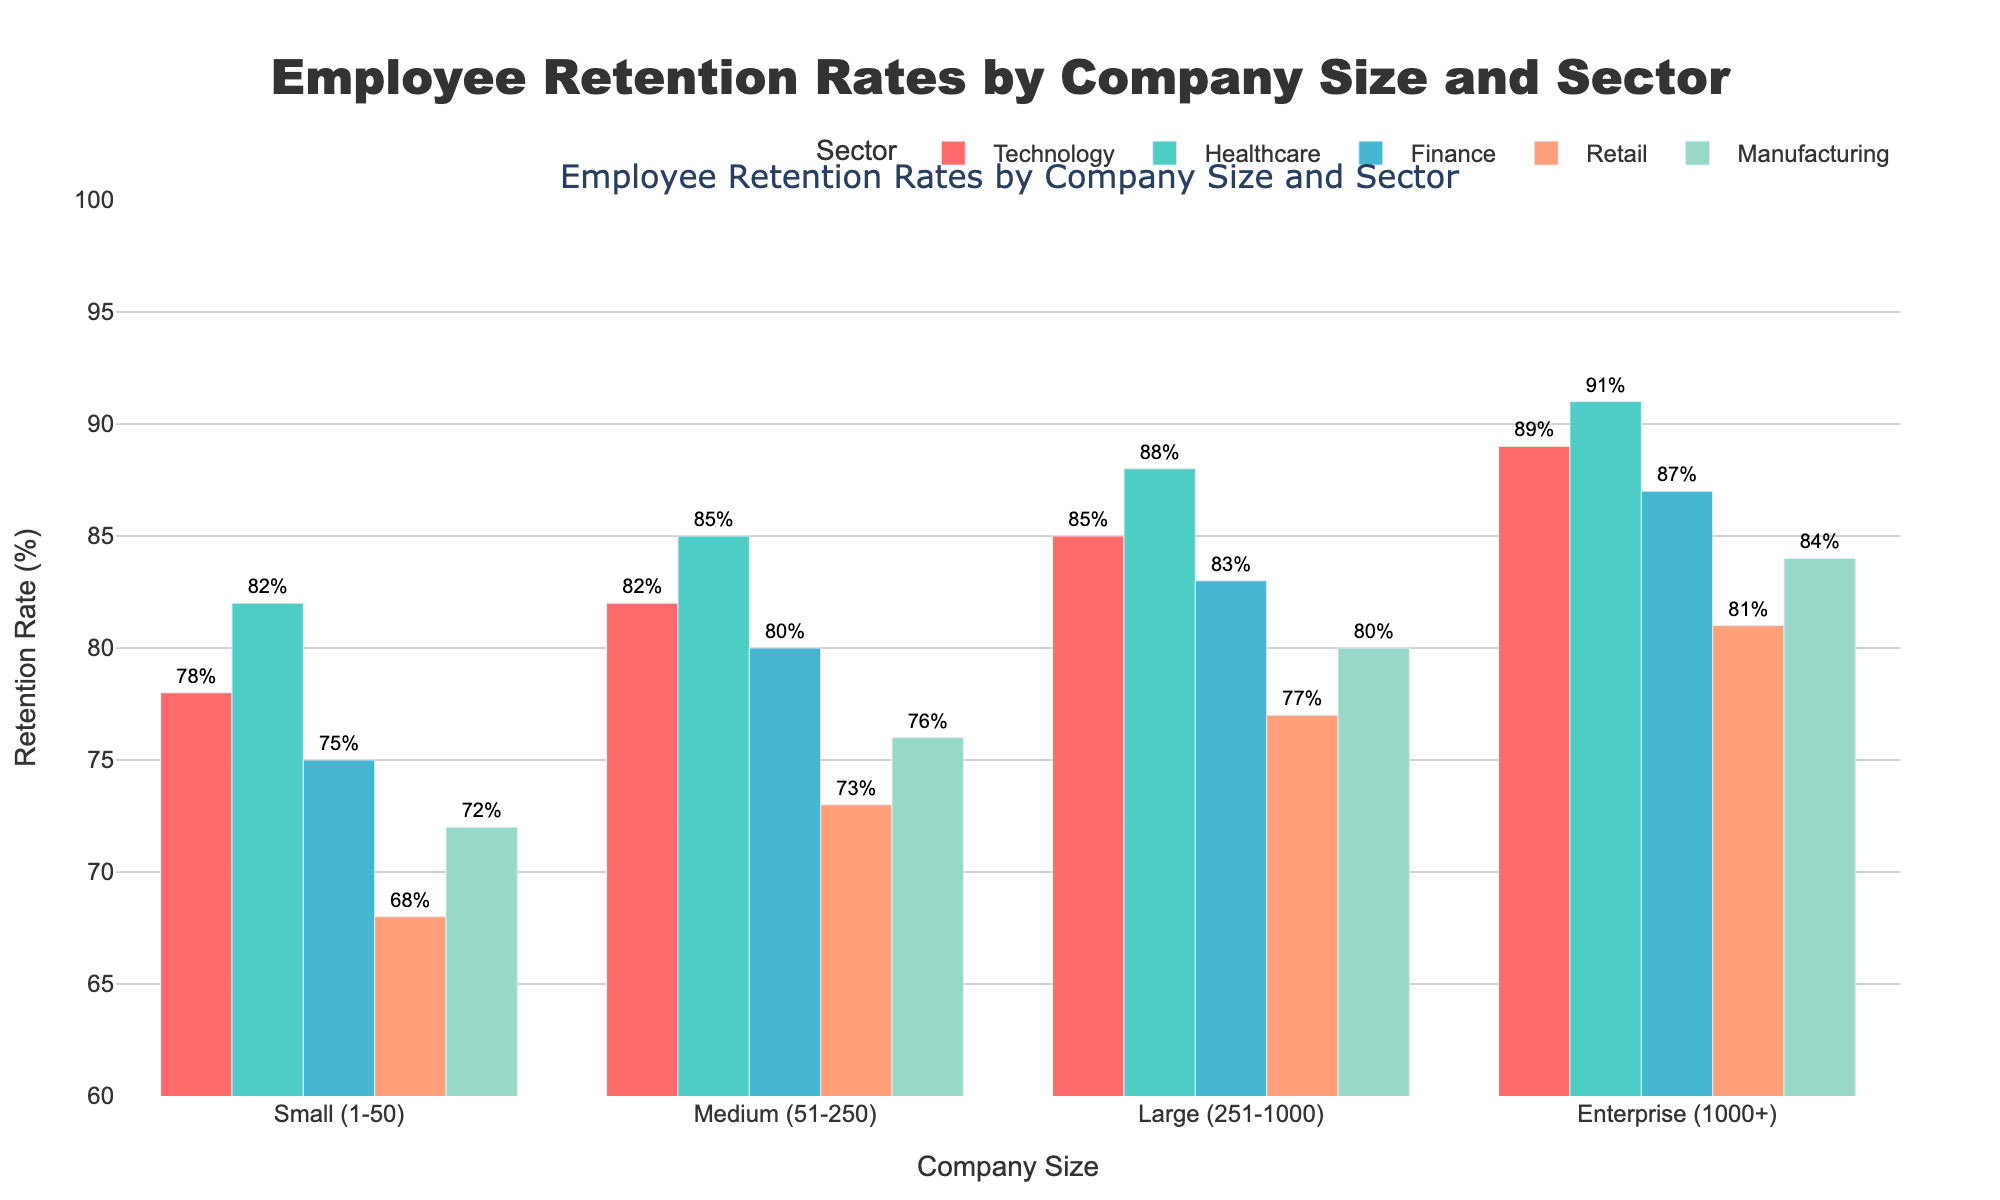Which sector has the highest retention rate in small companies? From the chart, we look at the bars for small companies (1-50) and identify the sector with the tallest bar. Healthcare has a retention rate of 82%, which is the highest among small companies.
Answer: Healthcare What is the difference in retention rates between medium and large companies in the Technology sector? We compare the bars for medium (51-250) and large (251-1000) companies in the Technology sector. The retention rate for medium is 82% and for large is 85%. The difference is 85% - 82% = 3%.
Answer: 3% Which company size has the lowest retention rate in the Retail sector? By examining the bars for different company sizes within the Retail sector, we find that small companies (1-50) have the shortest bar with a retention rate of 68%.
Answer: Small (1-50) Across all sectors, which has the highest retention rate and in which company size? We look at all bars to find the highest one. The highest retention rate is 91% in the Healthcare sector for enterprise-sized companies (1000+).
Answer: Healthcare, Enterprise (1000+) What is the average retention rate for the Manufacturing sector across all company sizes? We add up the retention rates for Manufacturing across all company sizes: 72 + 76 + 80 + 84 = 312. There are 4 company sizes, so the average is 312 / 4 = 78%.
Answer: 78% Is the retention rate generally higher for larger companies within each sector? By comparing the heights of the bars within each sector from small to enterprise, we observe that the retention rates generally increase as the company size gets larger.
Answer: Yes By how much does the retention rate in the Finance sector for enterprise-sized companies exceed that of medium-sized companies? We compare the retention rates in the Finance sector for enterprise (87%) and medium (80%) companies. The difference is 87% - 80% = 7%.
Answer: 7% Which sector has the least variation in retention rates across different company sizes? We assess the bars in each sector and observe their variations. The Manufacturing sector has the closest retention rates across different company sizes ranging from 72% to 84%, with a range of 12 percentage points.
Answer: Manufacturing What is the range of retention rates for the Retail sector? We identify the highest and lowest retention rates for the Retail sector. The lowest is 68% (small companies) and the highest is 81% (enterprise companies), so the range is 81% - 68% = 13%.
Answer: 13% In which sector are the retention rates more uniform across different company sizes, Technology or Finance? We compare the bars for Technology and Finance sectors. The retention rates for Technology are 78%, 82%, 85%, and 89%, while for Finance they are 75%, 80%, 83%, and 87%. The differences are smaller for Finance (12 percentage points) compared to Technology (11 percentage points), suggesting more uniformity in Finance.
Answer: Technology 